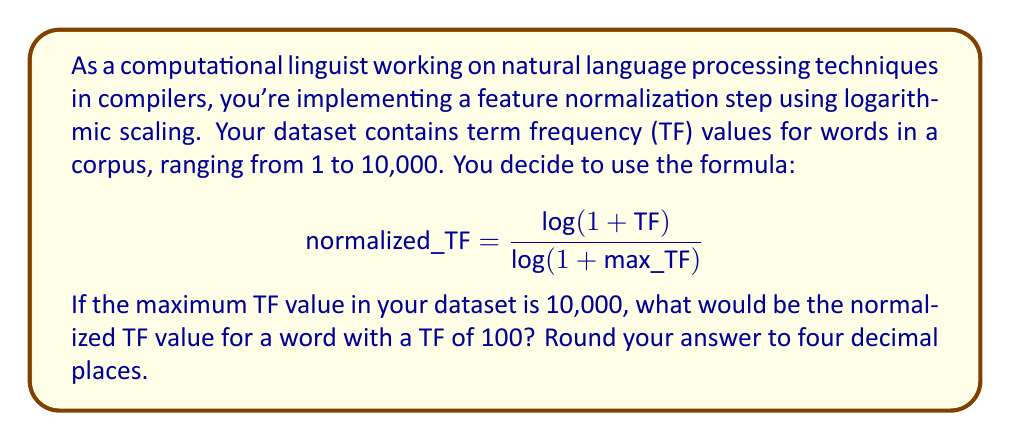Provide a solution to this math problem. Let's approach this step-by-step:

1) We're given the formula for normalization:
   $$ \text{normalized\_TF} = \frac{\log(1 + \text{TF})}{\log(1 + \text{max\_TF})} $$

2) We know that:
   - $\text{max\_TF} = 10,000$
   - $\text{TF} = 100$ for the word we're interested in

3) Let's substitute these values into our formula:
   $$ \text{normalized\_TF} = \frac{\log(1 + 100)}{\log(1 + 10,000)} $$

4) Now, let's calculate the numerator:
   $\log(1 + 100) = \log(101) \approx 4.6151$

5) Next, let's calculate the denominator:
   $\log(1 + 10,000) = \log(10,001) \approx 9.2103$

6) Now we can divide:
   $$ \text{normalized\_TF} = \frac{4.6151}{9.2103} \approx 0.5011 $$

7) Rounding to four decimal places, we get 0.5011.

This logarithmic scaling helps to reduce the impact of very high frequency terms, which is often desirable in NLP applications. It compresses the range of values while maintaining the relative order, which can be particularly useful when dealing with power-law distributions often found in natural language data.
Answer: 0.5011 